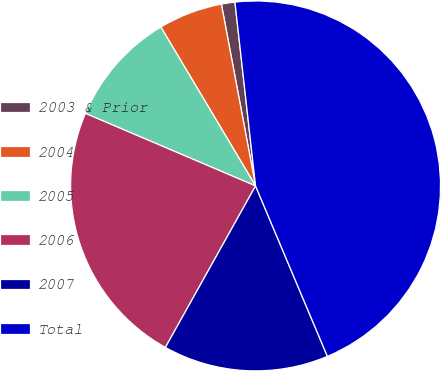<chart> <loc_0><loc_0><loc_500><loc_500><pie_chart><fcel>2003 & Prior<fcel>2004<fcel>2005<fcel>2006<fcel>2007<fcel>Total<nl><fcel>1.18%<fcel>5.6%<fcel>10.03%<fcel>23.31%<fcel>14.45%<fcel>45.43%<nl></chart> 